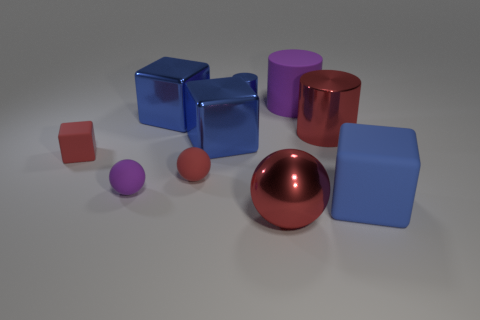How many blue cubes must be subtracted to get 1 blue cubes? 2 Subtract all metallic cylinders. How many cylinders are left? 1 Subtract all blue cubes. How many cubes are left? 1 Subtract all cylinders. How many objects are left? 7 Subtract all gray blocks. How many red balls are left? 2 Add 6 metal blocks. How many metal blocks are left? 8 Add 8 big rubber cylinders. How many big rubber cylinders exist? 9 Subtract 0 yellow cubes. How many objects are left? 10 Subtract 2 balls. How many balls are left? 1 Subtract all purple spheres. Subtract all purple cylinders. How many spheres are left? 2 